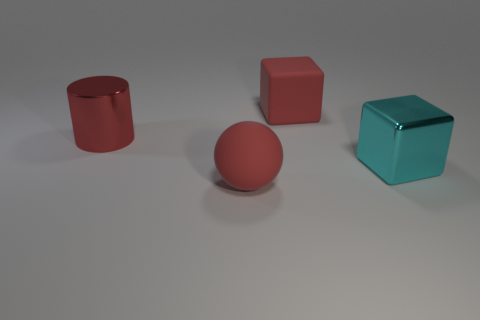Subtract all spheres. How many objects are left? 3 Add 4 large red things. How many objects exist? 8 Subtract 1 spheres. How many spheres are left? 0 Add 1 large cylinders. How many large cylinders are left? 2 Add 3 big red matte cubes. How many big red matte cubes exist? 4 Subtract 0 purple cylinders. How many objects are left? 4 Subtract all red blocks. Subtract all brown spheres. How many blocks are left? 1 Subtract all brown cylinders. How many yellow blocks are left? 0 Subtract all large rubber cubes. Subtract all big cyan metallic things. How many objects are left? 2 